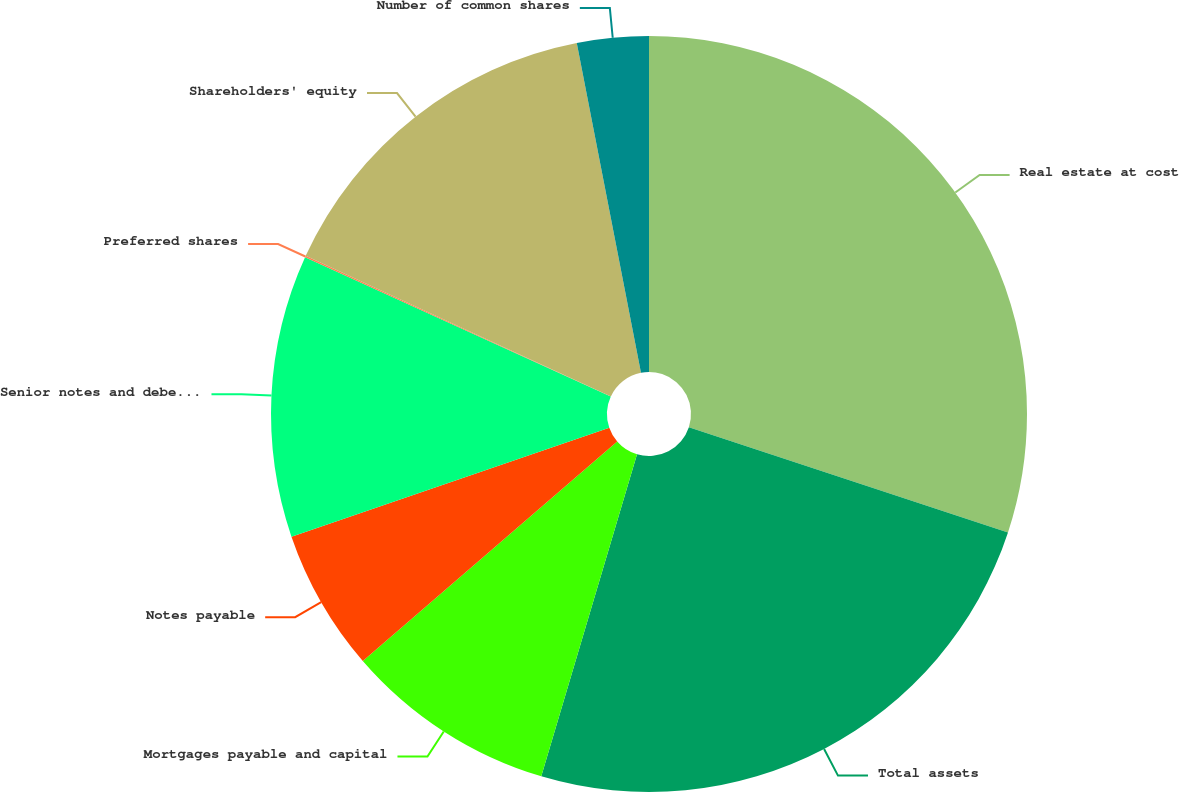<chart> <loc_0><loc_0><loc_500><loc_500><pie_chart><fcel>Real estate at cost<fcel>Total assets<fcel>Mortgages payable and capital<fcel>Notes payable<fcel>Senior notes and debentures<fcel>Preferred shares<fcel>Shareholders' equity<fcel>Number of common shares<nl><fcel>30.07%<fcel>24.53%<fcel>9.07%<fcel>6.07%<fcel>12.07%<fcel>0.06%<fcel>15.07%<fcel>3.06%<nl></chart> 